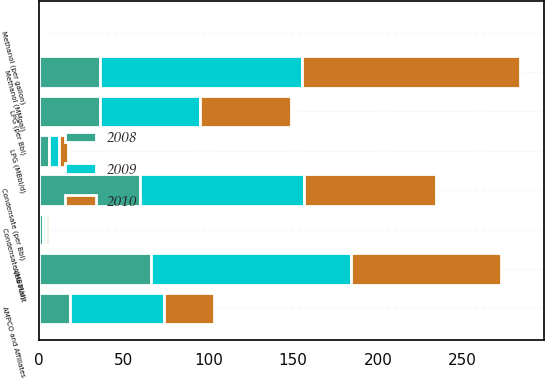<chart> <loc_0><loc_0><loc_500><loc_500><stacked_bar_chart><ecel><fcel>AMPCO and Affiliates<fcel>Alba Plant<fcel>Methanol (MMgal)<fcel>Condensate (MBbl/d)<fcel>LPG (MBbl/d)<fcel>Methanol (per gallon)<fcel>Condensate (per Bbl)<fcel>LPG (per Bbl)<nl><fcel>2010<fcel>29<fcel>89<fcel>129<fcel>2<fcel>5<fcel>0.84<fcel>77.98<fcel>53.68<nl><fcel>2008<fcel>18<fcel>66<fcel>36.03<fcel>2<fcel>6<fcel>0.6<fcel>59.51<fcel>36.03<nl><fcel>2009<fcel>56<fcel>118<fcel>119<fcel>2<fcel>6<fcel>1.25<fcel>96.77<fcel>58.81<nl></chart> 